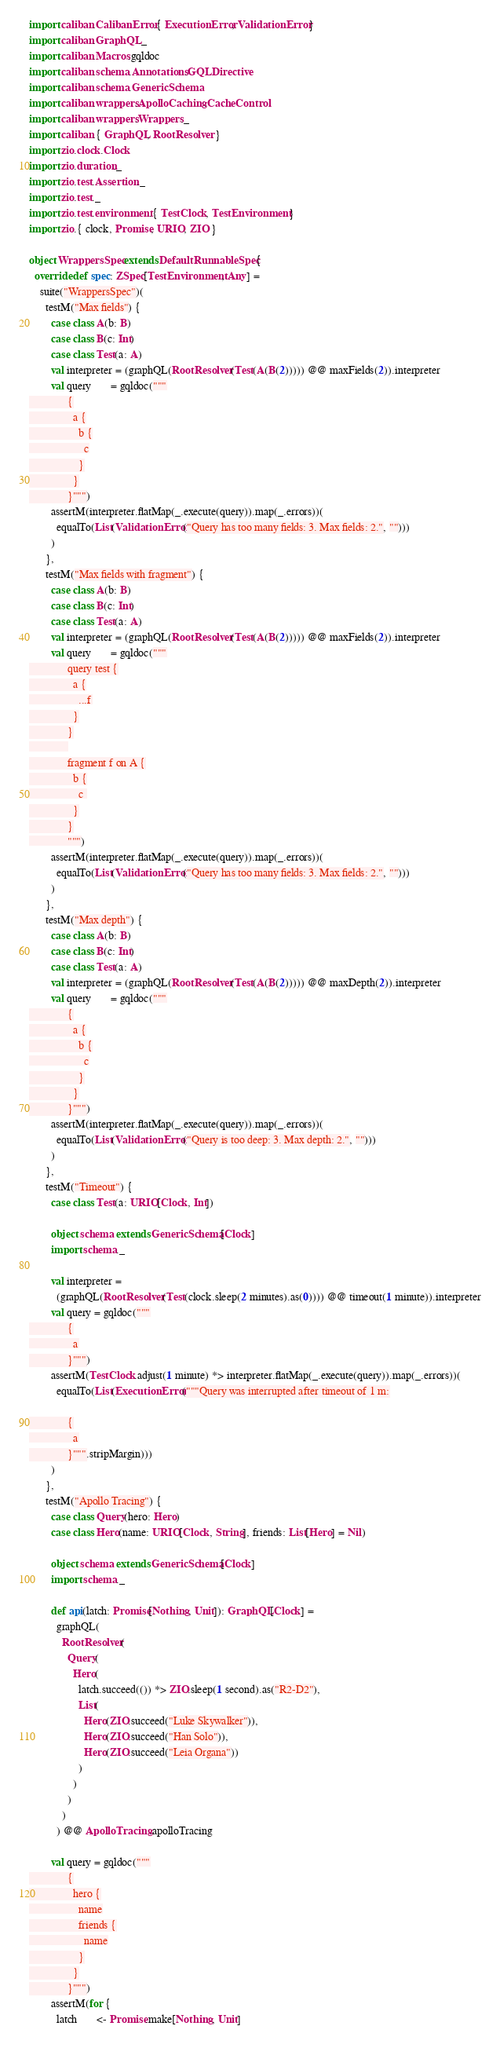<code> <loc_0><loc_0><loc_500><loc_500><_Scala_>import caliban.CalibanError.{ ExecutionError, ValidationError }
import caliban.GraphQL._
import caliban.Macros.gqldoc
import caliban.schema.Annotations.GQLDirective
import caliban.schema.GenericSchema
import caliban.wrappers.ApolloCaching.CacheControl
import caliban.wrappers.Wrappers._
import caliban.{ GraphQL, RootResolver }
import zio.clock.Clock
import zio.duration._
import zio.test.Assertion._
import zio.test._
import zio.test.environment.{ TestClock, TestEnvironment }
import zio.{ clock, Promise, URIO, ZIO }

object WrappersSpec extends DefaultRunnableSpec {
  override def spec: ZSpec[TestEnvironment, Any] =
    suite("WrappersSpec")(
      testM("Max fields") {
        case class A(b: B)
        case class B(c: Int)
        case class Test(a: A)
        val interpreter = (graphQL(RootResolver(Test(A(B(2))))) @@ maxFields(2)).interpreter
        val query       = gqldoc("""
              {
                a {
                  b {
                    c
                  }
                }
              }""")
        assertM(interpreter.flatMap(_.execute(query)).map(_.errors))(
          equalTo(List(ValidationError("Query has too many fields: 3. Max fields: 2.", "")))
        )
      },
      testM("Max fields with fragment") {
        case class A(b: B)
        case class B(c: Int)
        case class Test(a: A)
        val interpreter = (graphQL(RootResolver(Test(A(B(2))))) @@ maxFields(2)).interpreter
        val query       = gqldoc("""
              query test {
                a {
                  ...f
                }
              }
              
              fragment f on A {
                b {
                  c 
                }
              }
              """)
        assertM(interpreter.flatMap(_.execute(query)).map(_.errors))(
          equalTo(List(ValidationError("Query has too many fields: 3. Max fields: 2.", "")))
        )
      },
      testM("Max depth") {
        case class A(b: B)
        case class B(c: Int)
        case class Test(a: A)
        val interpreter = (graphQL(RootResolver(Test(A(B(2))))) @@ maxDepth(2)).interpreter
        val query       = gqldoc("""
              {
                a {
                  b {
                    c
                  }
                }
              }""")
        assertM(interpreter.flatMap(_.execute(query)).map(_.errors))(
          equalTo(List(ValidationError("Query is too deep: 3. Max depth: 2.", "")))
        )
      },
      testM("Timeout") {
        case class Test(a: URIO[Clock, Int])

        object schema extends GenericSchema[Clock]
        import schema._

        val interpreter =
          (graphQL(RootResolver(Test(clock.sleep(2 minutes).as(0)))) @@ timeout(1 minute)).interpreter
        val query = gqldoc("""
              {
                a
              }""")
        assertM(TestClock.adjust(1 minute) *> interpreter.flatMap(_.execute(query)).map(_.errors))(
          equalTo(List(ExecutionError("""Query was interrupted after timeout of 1 m:

              {
                a
              }""".stripMargin)))
        )
      },
      testM("Apollo Tracing") {
        case class Query(hero: Hero)
        case class Hero(name: URIO[Clock, String], friends: List[Hero] = Nil)

        object schema extends GenericSchema[Clock]
        import schema._

        def api(latch: Promise[Nothing, Unit]): GraphQL[Clock] =
          graphQL(
            RootResolver(
              Query(
                Hero(
                  latch.succeed(()) *> ZIO.sleep(1 second).as("R2-D2"),
                  List(
                    Hero(ZIO.succeed("Luke Skywalker")),
                    Hero(ZIO.succeed("Han Solo")),
                    Hero(ZIO.succeed("Leia Organa"))
                  )
                )
              )
            )
          ) @@ ApolloTracing.apolloTracing

        val query = gqldoc("""
              {
                hero {
                  name
                  friends {
                    name
                  }
                }
              }""")
        assertM(for {
          latch       <- Promise.make[Nothing, Unit]</code> 